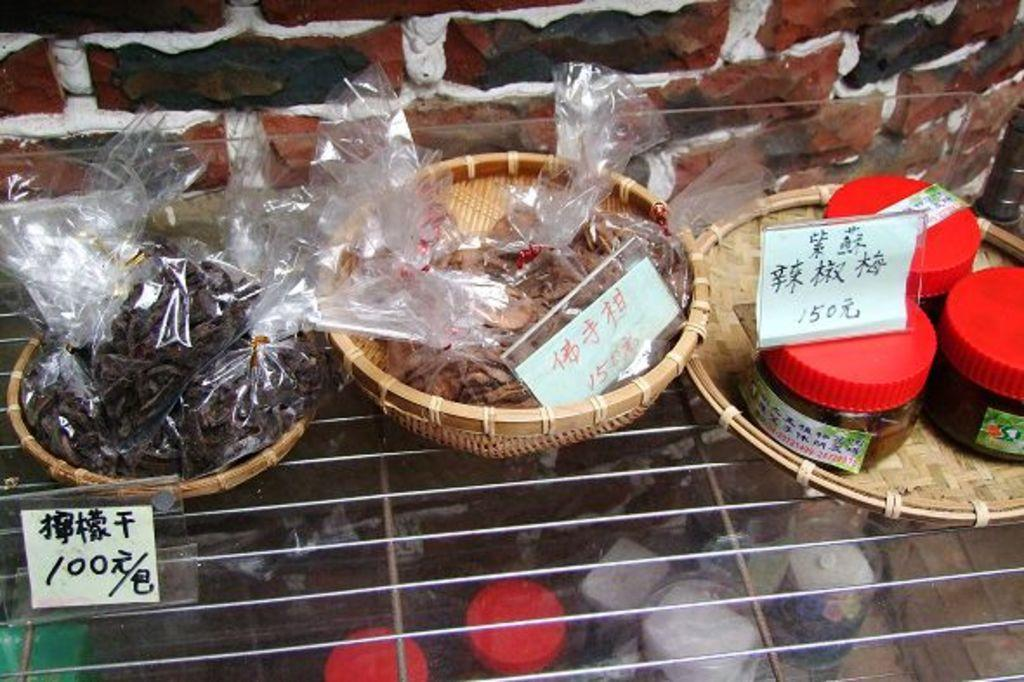What type of plate is used to hold the eatables in the image? There is a wooden plate used to hold the eatables in the image. What other type of dishware is present in the image? There are wooden bowls in the image. What material is the tray in the image made of? The tray in the image is made of steel. What can be seen below the steel tray in the image? There are other objects below the steel tray in the image. What grade did the volcano receive in the image? There is no volcano present in the image, so it cannot receive a grade. 